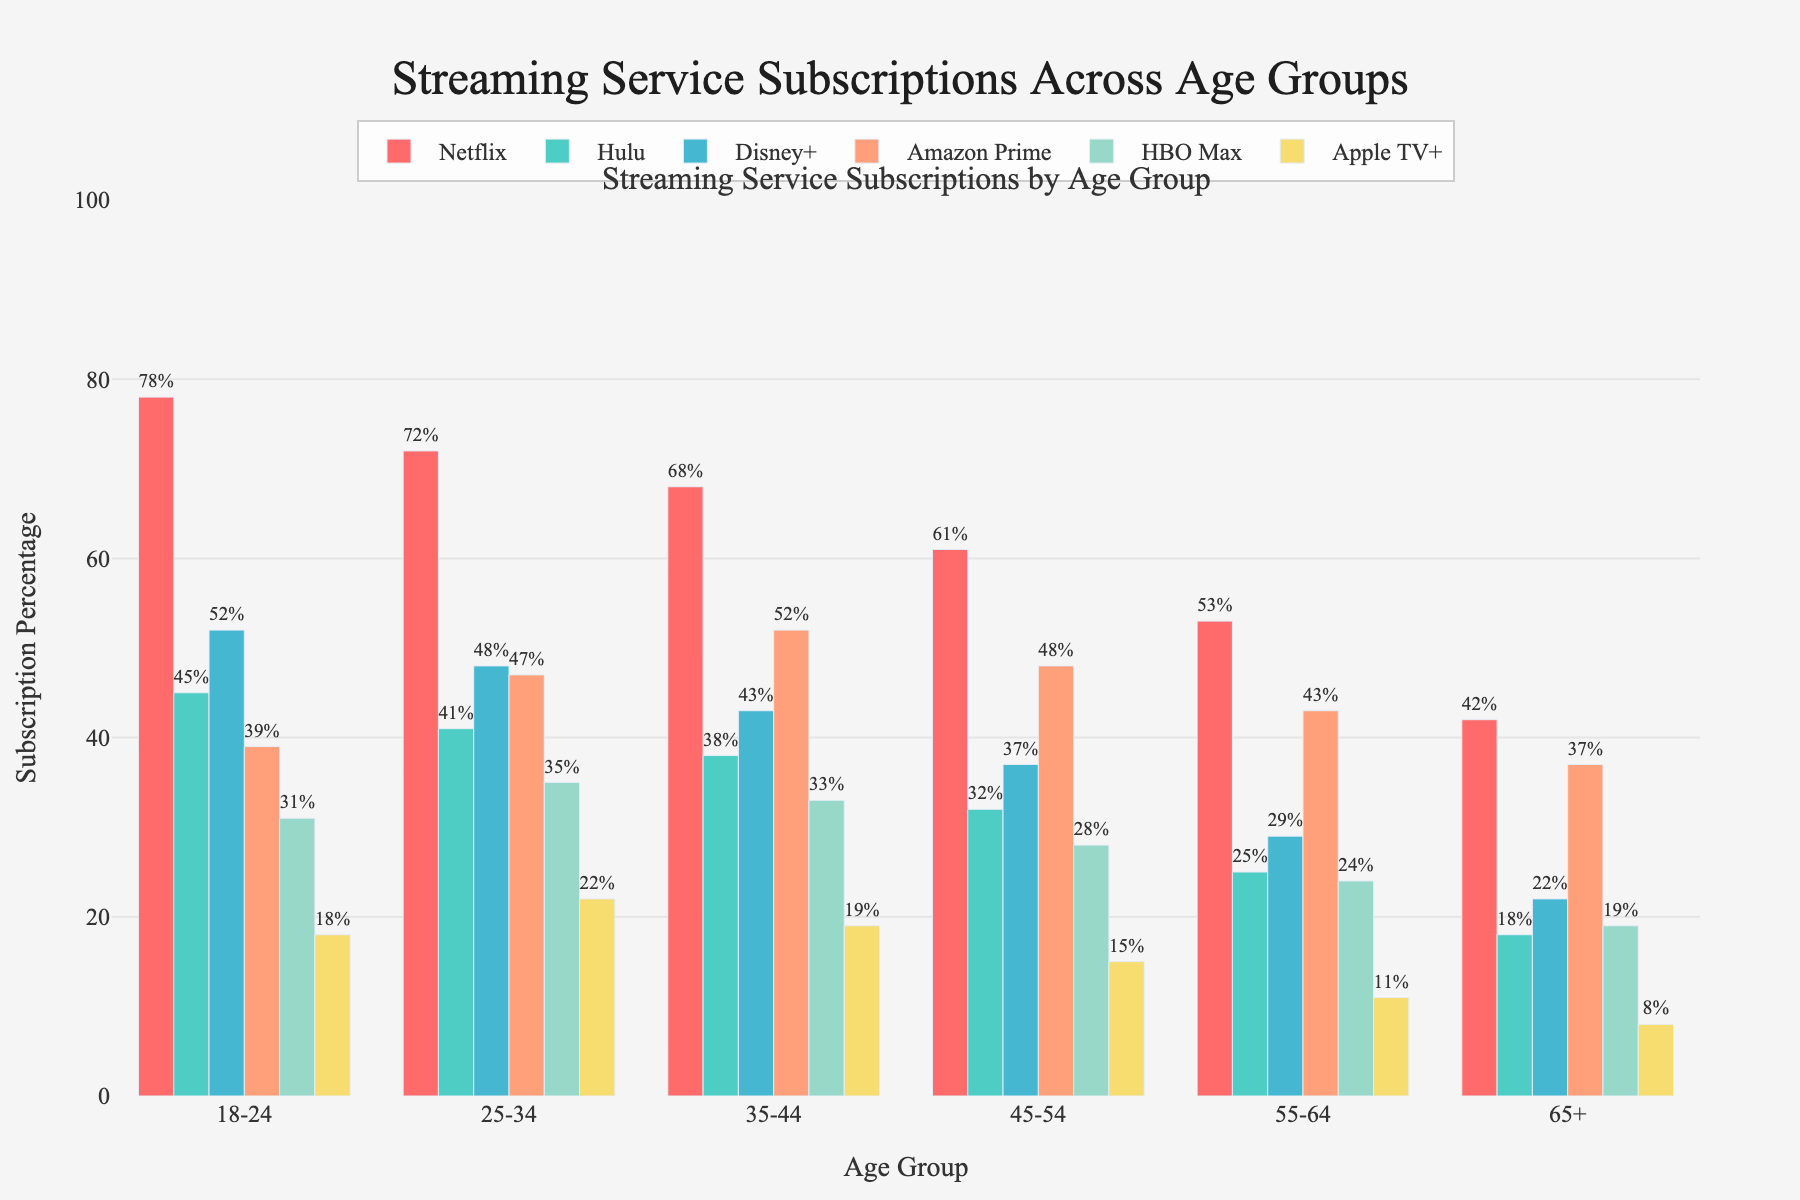What's the most popular streaming service among the 18-24 age group? According to the figure, the highest bar within the 18-24 age group category represents Netflix.
Answer: Netflix Which streaming service has the smallest percentage of subscribers among the 65+ age group? By examining the height of the bars within the 65+ age group, the lowest bar corresponds to Apple TV+ with 8%.
Answer: Apple TV+ What's the difference in Netflix subscription percentages between the 18-24 and 65+ age groups? The percentage for the 18-24 age group is 78%, while for the 65+ group, it's 42%. The difference is 78% - 42% = 36%.
Answer: 36% How does the subscription percentage of Disney+ compare between the 35-44 and 55-64 age groups? Looking at the bars for Disney+, the percentage for the 35-44 age group is 43%, while for the 55-64 age group, it's 29%. Disney+ is more popular among 35-44 year-olds by 14%.
Answer: 43% for 35-44, 29% for 55-64 Which age group has the highest subscription rate for Amazon Prime? By comparing the bars for Amazon Prime across all age groups, the highest bar is for the 35-44 age group at 52%.
Answer: 35-44 What is the average subscription percentage of HBO Max across all age groups? Sum the percentages for HBO Max across all age groups (31% + 35% + 33% + 28% + 24% + 19%) and divide by the number of age groups (6). The average is (31% + 35% + 33% + 28% + 24% + 19%) / 6 = 28.33%.
Answer: 28.33% Which streaming service has the most similar subscription percentages between the 18-24 and 25-34 age groups? Comparing the differences in subscription percentages between the 18-24 and 25-34 age groups for each service:
- Netflix: 78% vs. 72% (6% difference)
- Hulu: 45% vs. 41% (4% difference)
- Disney+: 52% vs. 48% (4% difference)
- Amazon Prime: 39% vs. 47% (8% difference)
- HBO Max: 31% vs. 35% (4% difference)
- Apple TV+: 18% vs. 22% (4% difference)
Hulu, Disney+, HBO Max, and Apple TV+ all have the smallest difference of 4%.
Answer: Hulu, Disney+, HBO Max, Apple TV+ What is the combined subscription percentage for Hulu and Apple TV+ in the 55-64 age group? For the 55-64 age group, the Hulu percentage is 25% and Apple TV+ is 11%. The combined percentage is 25% + 11% = 36%.
Answer: 36% Which age group has the lowest overall subscription percentage for all the services combined? Add up the percentages for all streaming services for each age group:
- 18-24: 78% + 45% + 52% + 39% + 31% + 18% = 263%
- 25-34: 72% + 41% + 48% + 47% + 35% + 22% = 265%
- 35-44: 68% + 38% + 43% + 52% + 33% + 19% = 253%
- 45-54: 61% + 32% + 37% + 48% + 28% + 15% = 221%
- 55-64: 53% + 25% + 29% + 43% + 24% + 11% = 185%
- 65+: 42% + 18% + 22% + 37% + 19% + 8% = 146%
The 65+ age group has the lowest overall subscription percentage at 146%.
Answer: 65+ 